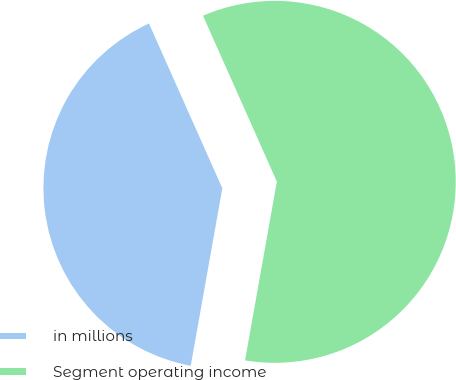Convert chart. <chart><loc_0><loc_0><loc_500><loc_500><pie_chart><fcel>in millions<fcel>Segment operating income<nl><fcel>40.53%<fcel>59.47%<nl></chart> 